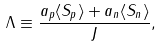<formula> <loc_0><loc_0><loc_500><loc_500>\Lambda \equiv \frac { a _ { p } \langle S _ { p } \rangle + a _ { n } \langle S _ { n } \rangle } { J } ,</formula> 